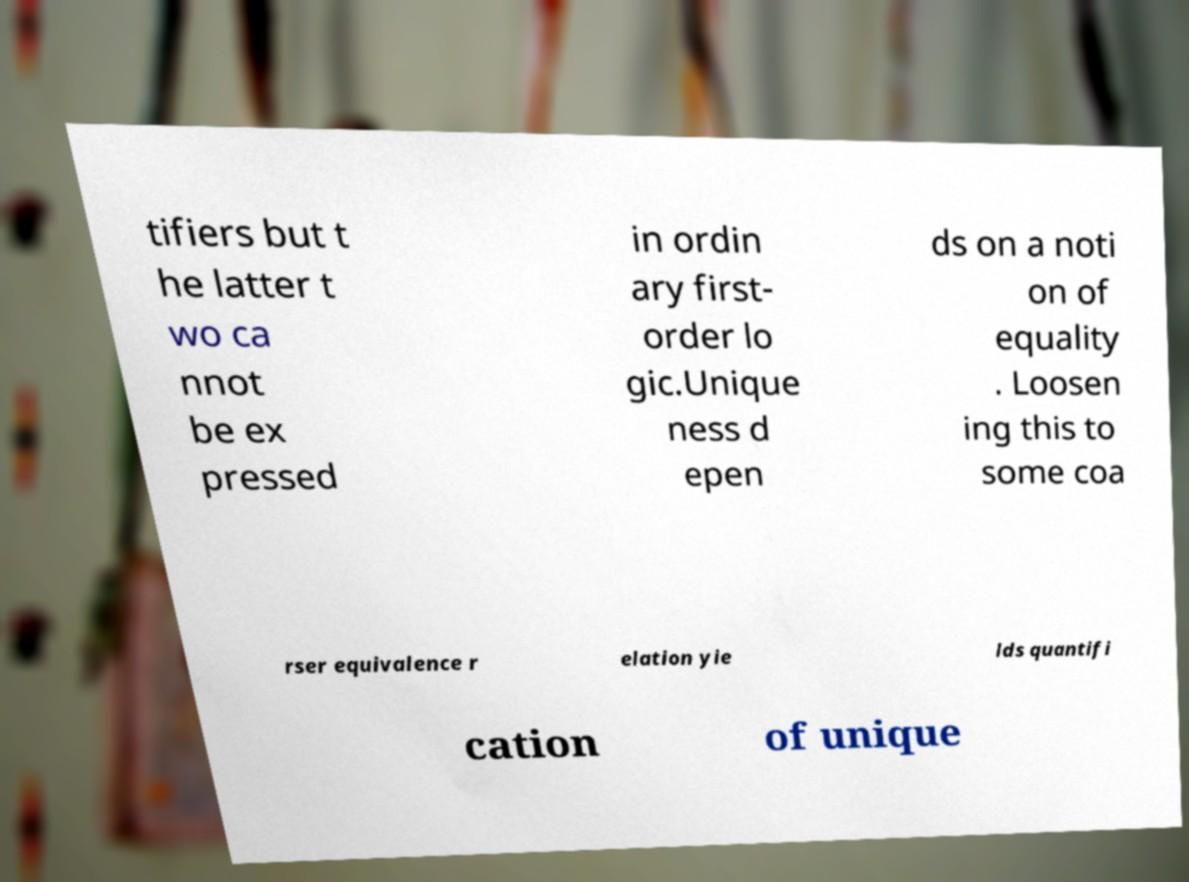There's text embedded in this image that I need extracted. Can you transcribe it verbatim? tifiers but t he latter t wo ca nnot be ex pressed in ordin ary first- order lo gic.Unique ness d epen ds on a noti on of equality . Loosen ing this to some coa rser equivalence r elation yie lds quantifi cation of unique 